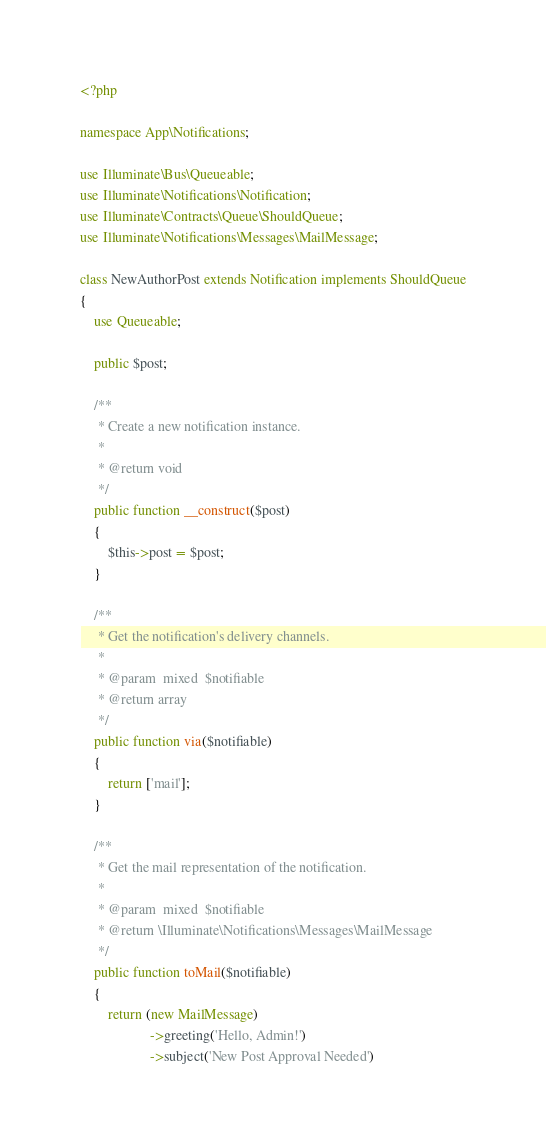<code> <loc_0><loc_0><loc_500><loc_500><_PHP_><?php

namespace App\Notifications;

use Illuminate\Bus\Queueable;
use Illuminate\Notifications\Notification;
use Illuminate\Contracts\Queue\ShouldQueue;
use Illuminate\Notifications\Messages\MailMessage;

class NewAuthorPost extends Notification implements ShouldQueue
{
    use Queueable;

    public $post;

    /**
     * Create a new notification instance.
     *
     * @return void
     */
    public function __construct($post)
    {
        $this->post = $post;
    }

    /**
     * Get the notification's delivery channels.
     *
     * @param  mixed  $notifiable
     * @return array
     */
    public function via($notifiable)
    {
        return ['mail'];
    }

    /**
     * Get the mail representation of the notification.
     *
     * @param  mixed  $notifiable
     * @return \Illuminate\Notifications\Messages\MailMessage
     */
    public function toMail($notifiable)
    {
        return (new MailMessage)
                    ->greeting('Hello, Admin!')
                    ->subject('New Post Approval Needed')</code> 